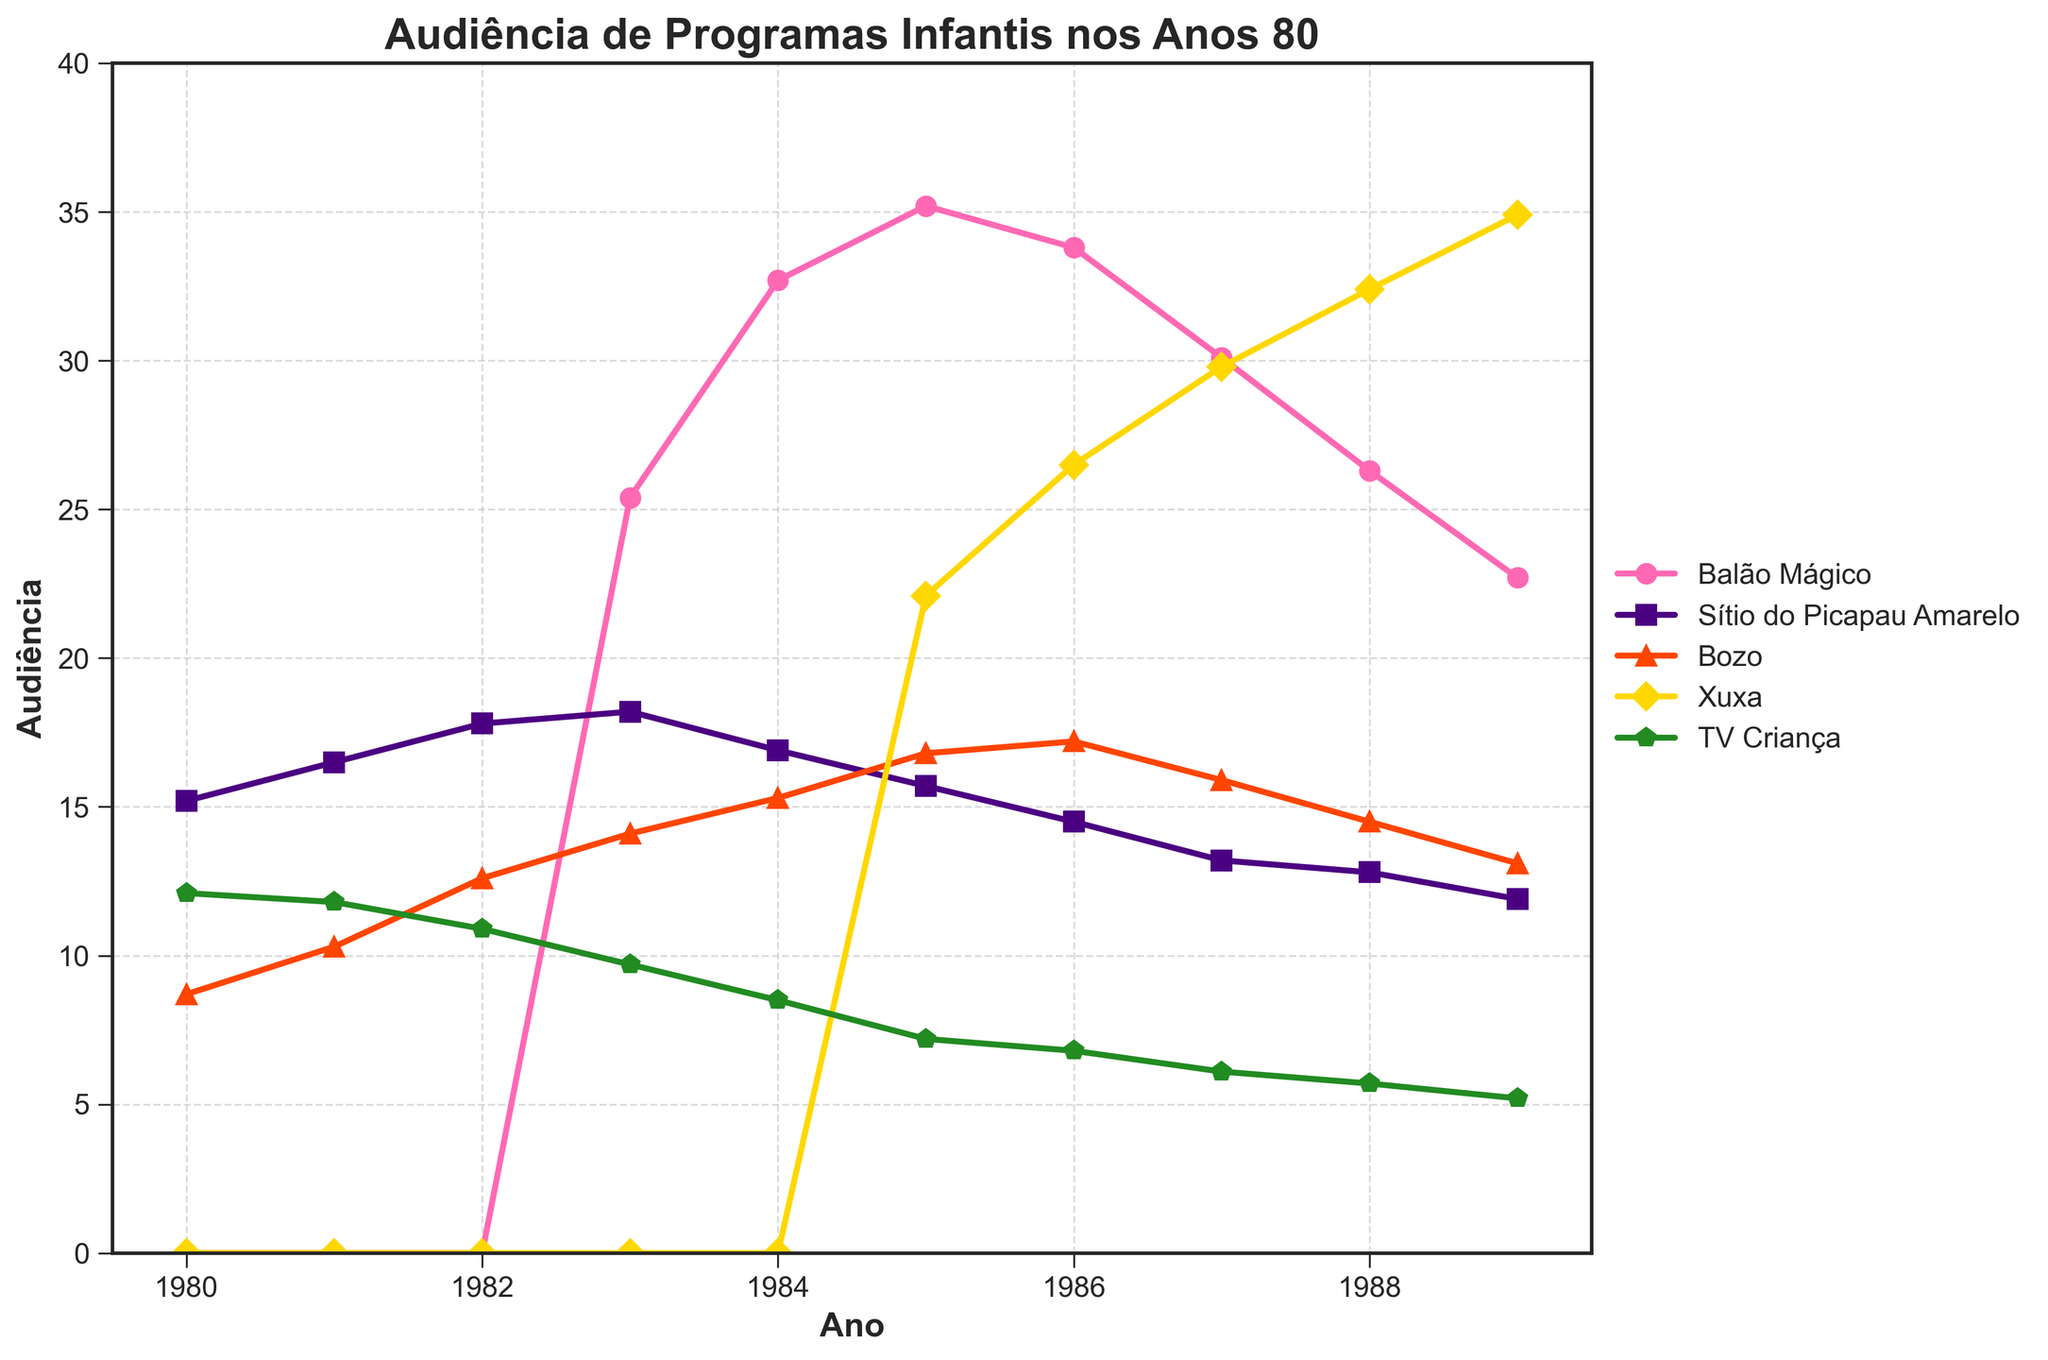Which TV show had the highest viewership rating in 1985? Look for the peak value in 1985 across all TV shows. Balão Mágico had the highest rating at 35.2.
Answer: Balão Mágico Between which years did Xuxa see a consistent increase in viewership ratings? Check the trend line for Xuxa from year to year. Xuxa’s ratings increased consistently from 1985 to 1989.
Answer: 1985 to 1989 Which show experienced a decline in ratings every year from 1986 to 1989? Check the ratings for each show from 1986 to 1989. Sítio do Picapau Amarelo had ratings that consistently declined each year.
Answer: Sítio do Picapau Amarelo What was the combined viewership rating of Balão Mágico and Bozo in 1984? Sum the ratings for Balão Mágico and Bozo in 1984 (32.7 + 15.3).
Answer: 48.0 Which TV show had the lowest viewership ratings in 1980? Look for the lowest value in the 1980 column. Balão Mágico had a rating of 0, which is the lowest.
Answer: Balão Mágico How much more popular was Xuxa compared to Bozo in 1989? Subtract Bozo's rating from Xuxa’s rating in 1989 (34.9 - 13.1).
Answer: 21.8 In which year did Balão Mágico experience the highest viewership rating? Check all the ratings for Balão Mágico and find the maximum, which occurred in 1985 with a rating of 35.2.
Answer: 1985 Which year did TV Criança have its largest decrease in viewership compared to the previous year? Look for the year with the largest drop by comparing year-by-year ratings for TV Criança. The largest decrease was from 1980 to 1981.
Answer: 1981 Compare the viewership ratings of Sítio do Picapau Amarelo between 1983 and 1988. Which year had a higher rating? Compare the values for Sítio do Picapau Amarelo in 1983 (18.2) and 1988 (12.8).
Answer: 1983 What was the trend in the viewership ratings for Bozo from 1983 to 1986? Observe the pattern in Bozo's ratings from 1983 to 1986. They increased each year.
Answer: Increasing 